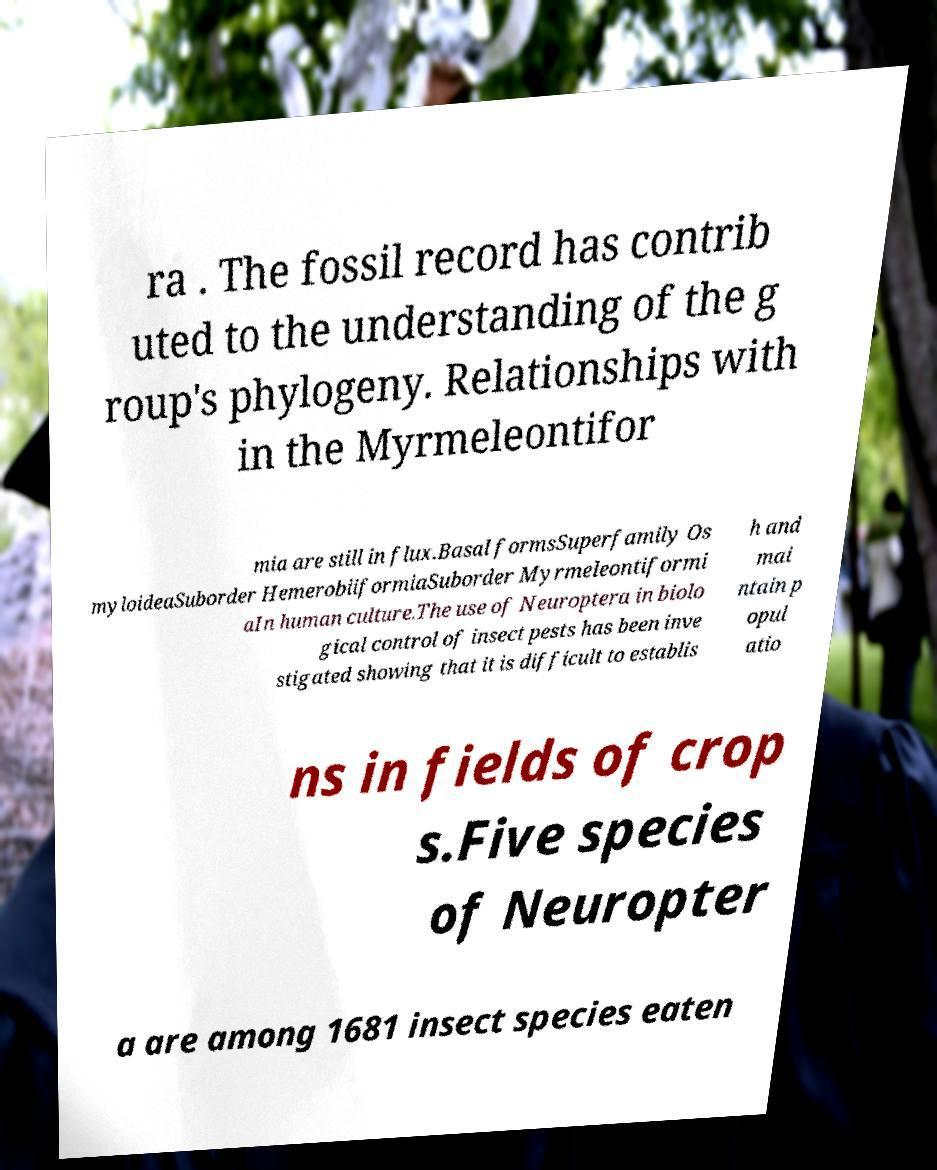Please read and relay the text visible in this image. What does it say? ra . The fossil record has contrib uted to the understanding of the g roup's phylogeny. Relationships with in the Myrmeleontifor mia are still in flux.Basal formsSuperfamily Os myloideaSuborder HemerobiiformiaSuborder Myrmeleontiformi aIn human culture.The use of Neuroptera in biolo gical control of insect pests has been inve stigated showing that it is difficult to establis h and mai ntain p opul atio ns in fields of crop s.Five species of Neuropter a are among 1681 insect species eaten 